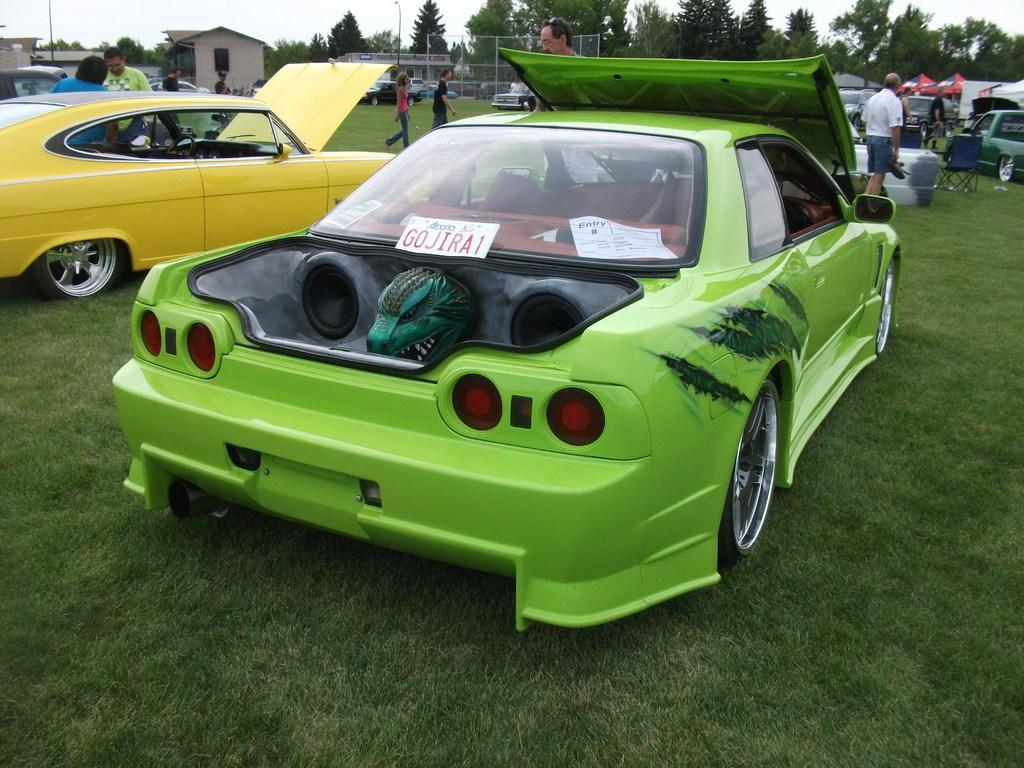Provide a one-sentence caption for the provided image. green car with monster head in trunk and license plate G0JIRA1 against rear window. 